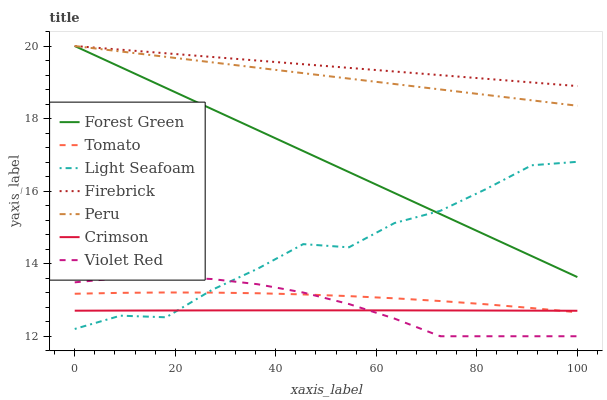Does Crimson have the minimum area under the curve?
Answer yes or no. Yes. Does Firebrick have the maximum area under the curve?
Answer yes or no. Yes. Does Violet Red have the minimum area under the curve?
Answer yes or no. No. Does Violet Red have the maximum area under the curve?
Answer yes or no. No. Is Peru the smoothest?
Answer yes or no. Yes. Is Light Seafoam the roughest?
Answer yes or no. Yes. Is Violet Red the smoothest?
Answer yes or no. No. Is Violet Red the roughest?
Answer yes or no. No. Does Violet Red have the lowest value?
Answer yes or no. Yes. Does Firebrick have the lowest value?
Answer yes or no. No. Does Peru have the highest value?
Answer yes or no. Yes. Does Violet Red have the highest value?
Answer yes or no. No. Is Light Seafoam less than Peru?
Answer yes or no. Yes. Is Forest Green greater than Tomato?
Answer yes or no. Yes. Does Violet Red intersect Crimson?
Answer yes or no. Yes. Is Violet Red less than Crimson?
Answer yes or no. No. Is Violet Red greater than Crimson?
Answer yes or no. No. Does Light Seafoam intersect Peru?
Answer yes or no. No. 